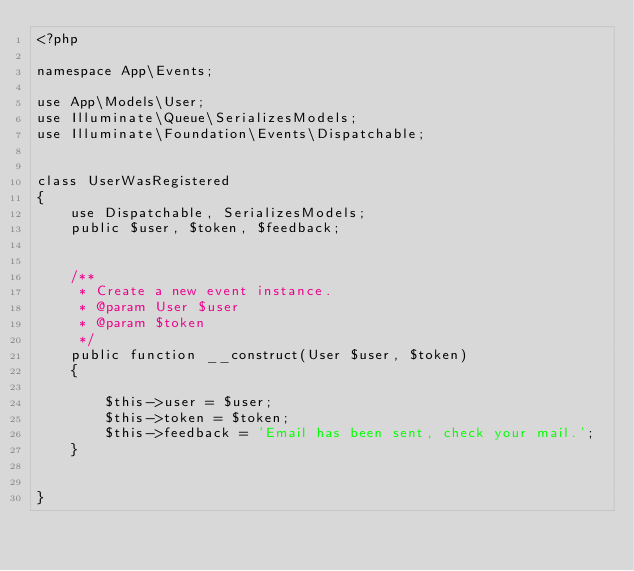Convert code to text. <code><loc_0><loc_0><loc_500><loc_500><_PHP_><?php

namespace App\Events;

use App\Models\User;
use Illuminate\Queue\SerializesModels;
use Illuminate\Foundation\Events\Dispatchable;


class UserWasRegistered
{
    use Dispatchable, SerializesModels;
    public $user, $token, $feedback;


    /**
     * Create a new event instance.
     * @param User $user
     * @param $token
     */
    public function __construct(User $user, $token)
    {

        $this->user = $user;
        $this->token = $token;
        $this->feedback = 'Email has been sent, check your mail.';
    }


}
</code> 